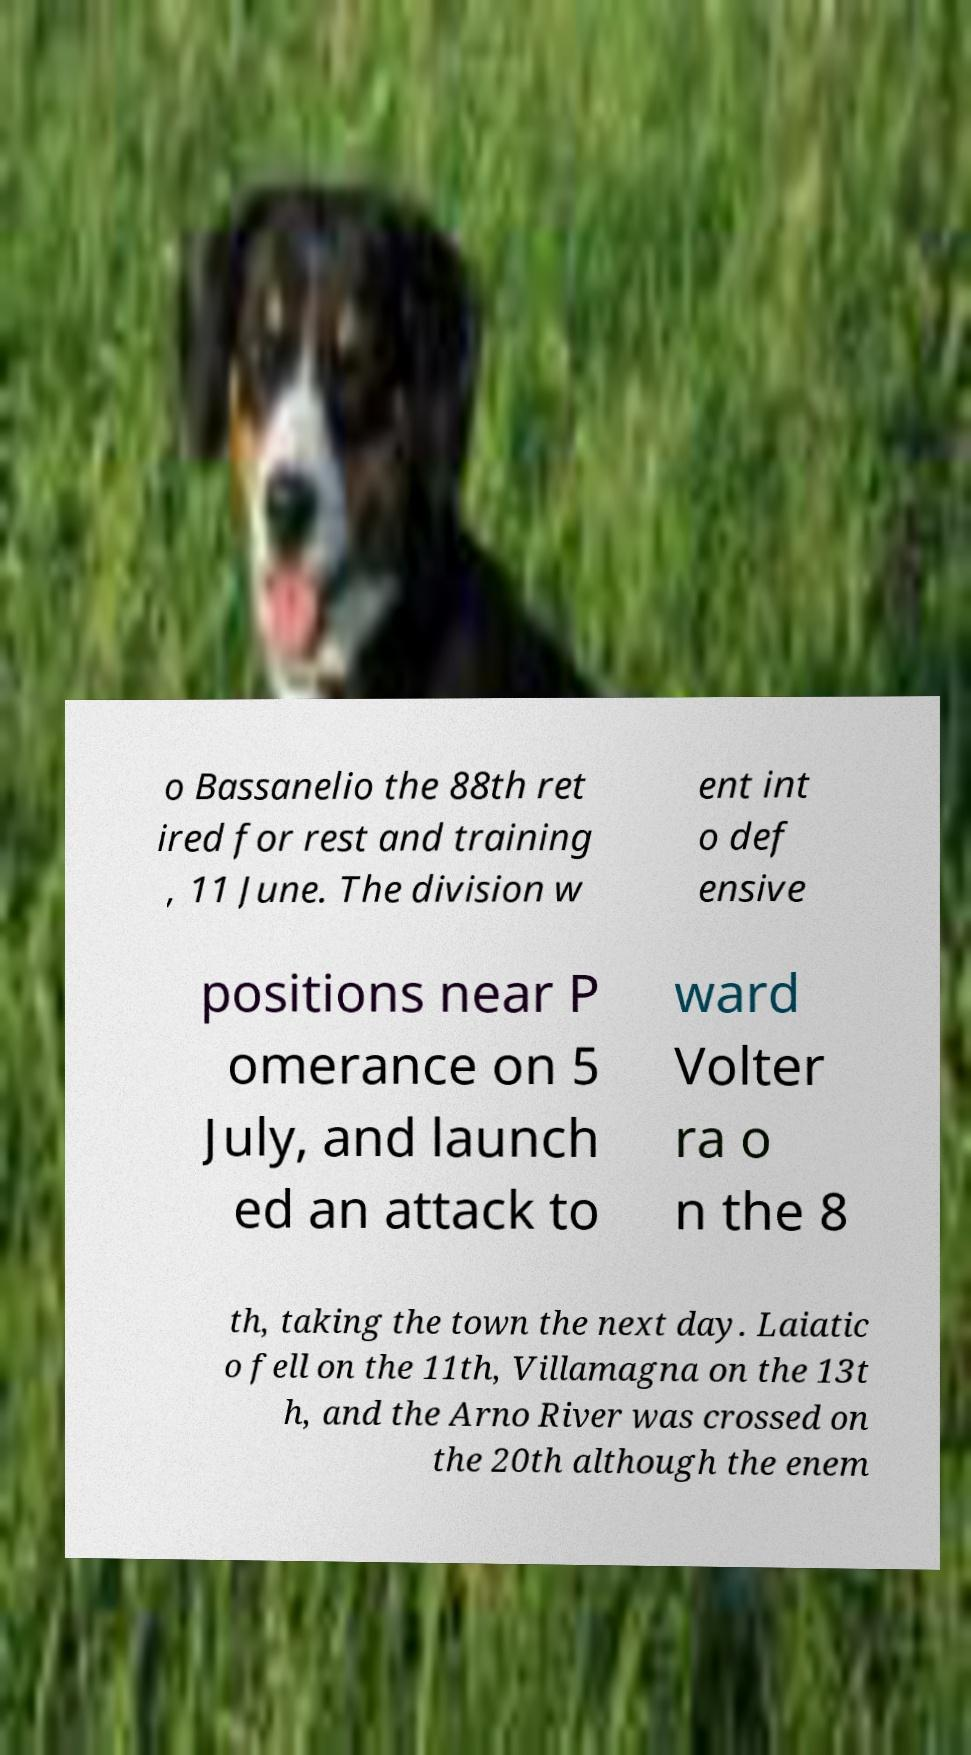Please identify and transcribe the text found in this image. o Bassanelio the 88th ret ired for rest and training , 11 June. The division w ent int o def ensive positions near P omerance on 5 July, and launch ed an attack to ward Volter ra o n the 8 th, taking the town the next day. Laiatic o fell on the 11th, Villamagna on the 13t h, and the Arno River was crossed on the 20th although the enem 